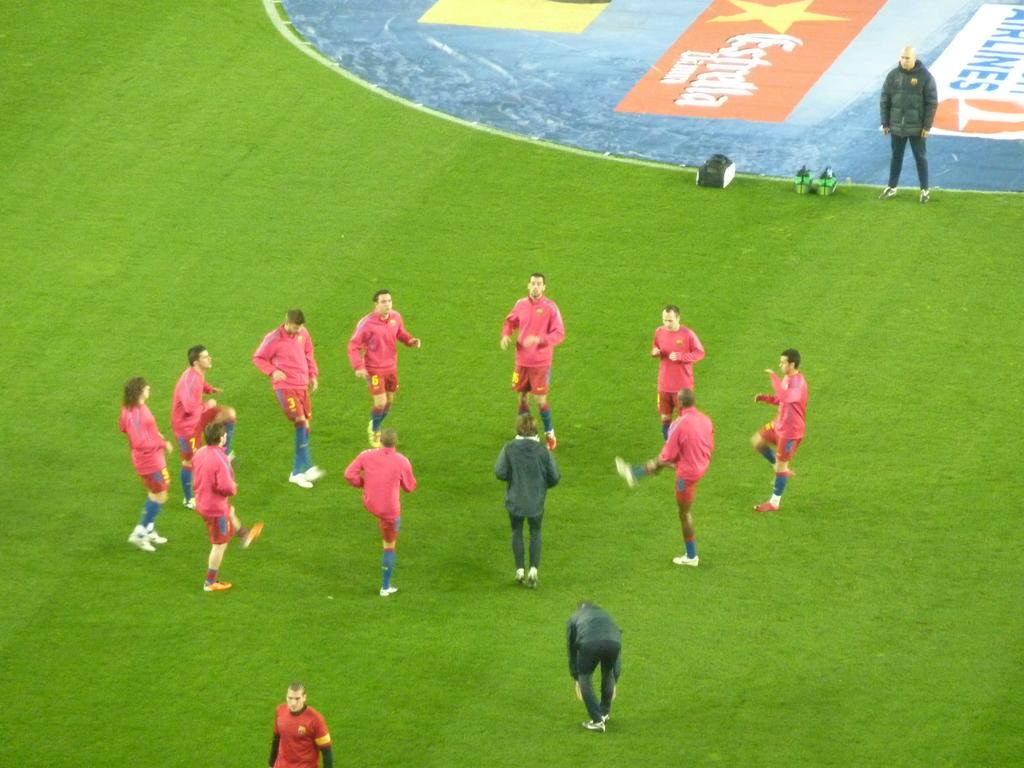What are the people in the image doing? The people in the image are doing warm-up exercises. Can you describe the person standing in the image? There is a person standing in the image, but no specific details are provided about their appearance or actions. What is the green surface in the image used for? There are objects on a green surface in the image, but the purpose of the green surface is not specified. What is visible in the background of the image? There is a hoarding visible in the image. How many pigs are present in the image? There are no pigs present in the image. What type of tax is being discussed in the image? There is no discussion of tax in the image. 